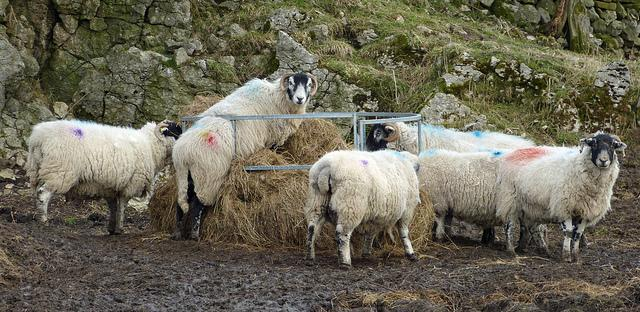What word is related to these animals? Please explain your reasoning. ewe. These are sheep and related to ewes 